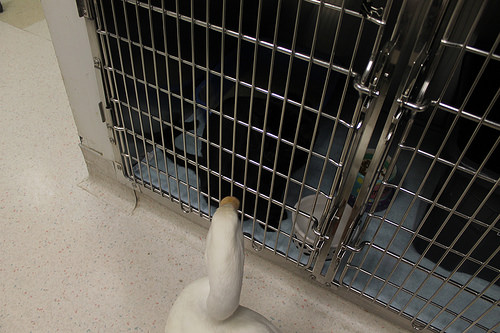<image>
Is the duck to the right of the cat? No. The duck is not to the right of the cat. The horizontal positioning shows a different relationship. 